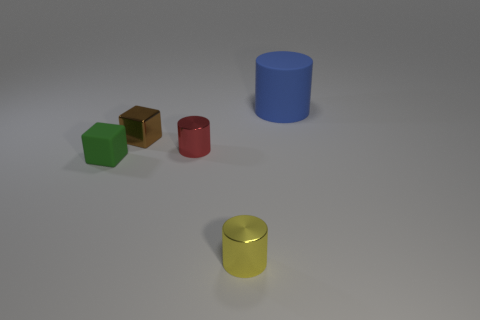How big is the metal cylinder that is in front of the tiny matte thing?
Offer a terse response. Small. Is the small green object made of the same material as the thing that is behind the shiny cube?
Provide a succinct answer. Yes. What number of big objects are on the left side of the matte thing that is left of the tiny thing behind the red object?
Offer a terse response. 0. What number of gray objects are either tiny metallic cylinders or large shiny balls?
Keep it short and to the point. 0. There is a matte thing in front of the small brown metallic cube; what is its shape?
Make the answer very short. Cube. What color is the rubber block that is the same size as the yellow shiny cylinder?
Provide a succinct answer. Green. Does the blue matte thing have the same shape as the rubber thing that is to the left of the yellow metal thing?
Offer a terse response. No. What material is the small cylinder that is to the left of the metal cylinder that is in front of the matte object in front of the big blue matte cylinder made of?
Make the answer very short. Metal. How many large things are brown things or brown cylinders?
Your response must be concise. 0. What number of other things are there of the same size as the blue rubber thing?
Provide a short and direct response. 0. 